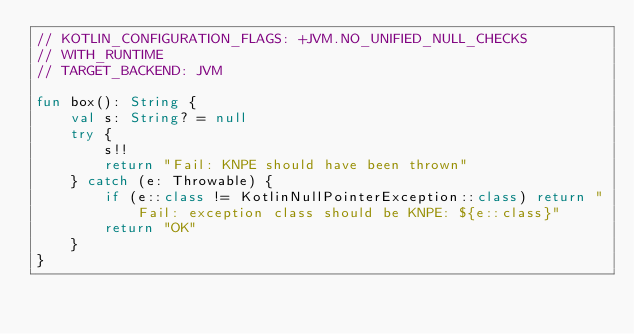<code> <loc_0><loc_0><loc_500><loc_500><_Kotlin_>// KOTLIN_CONFIGURATION_FLAGS: +JVM.NO_UNIFIED_NULL_CHECKS
// WITH_RUNTIME
// TARGET_BACKEND: JVM

fun box(): String {
    val s: String? = null
    try {
        s!!
        return "Fail: KNPE should have been thrown"
    } catch (e: Throwable) {
        if (e::class != KotlinNullPointerException::class) return "Fail: exception class should be KNPE: ${e::class}"
        return "OK"
    }
}
</code> 